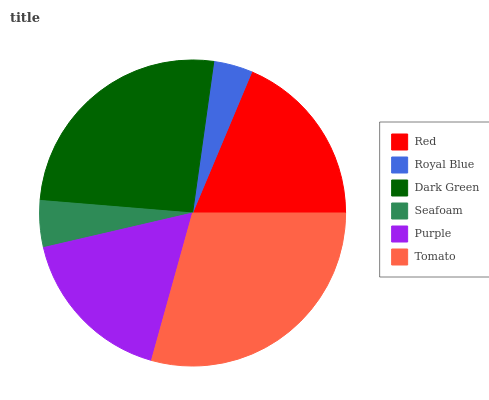Is Royal Blue the minimum?
Answer yes or no. Yes. Is Tomato the maximum?
Answer yes or no. Yes. Is Dark Green the minimum?
Answer yes or no. No. Is Dark Green the maximum?
Answer yes or no. No. Is Dark Green greater than Royal Blue?
Answer yes or no. Yes. Is Royal Blue less than Dark Green?
Answer yes or no. Yes. Is Royal Blue greater than Dark Green?
Answer yes or no. No. Is Dark Green less than Royal Blue?
Answer yes or no. No. Is Red the high median?
Answer yes or no. Yes. Is Purple the low median?
Answer yes or no. Yes. Is Purple the high median?
Answer yes or no. No. Is Royal Blue the low median?
Answer yes or no. No. 